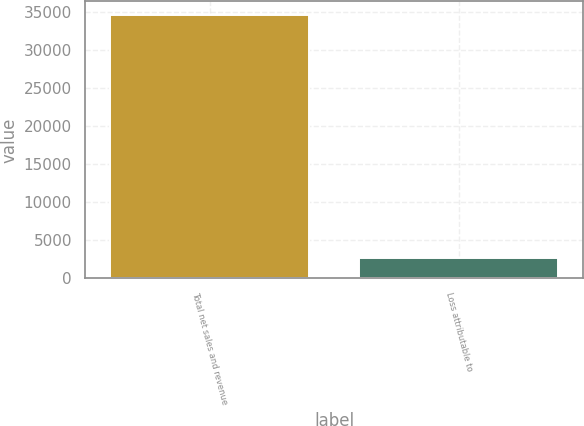<chart> <loc_0><loc_0><loc_500><loc_500><bar_chart><fcel>Total net sales and revenue<fcel>Loss attributable to<nl><fcel>34647<fcel>2625<nl></chart> 